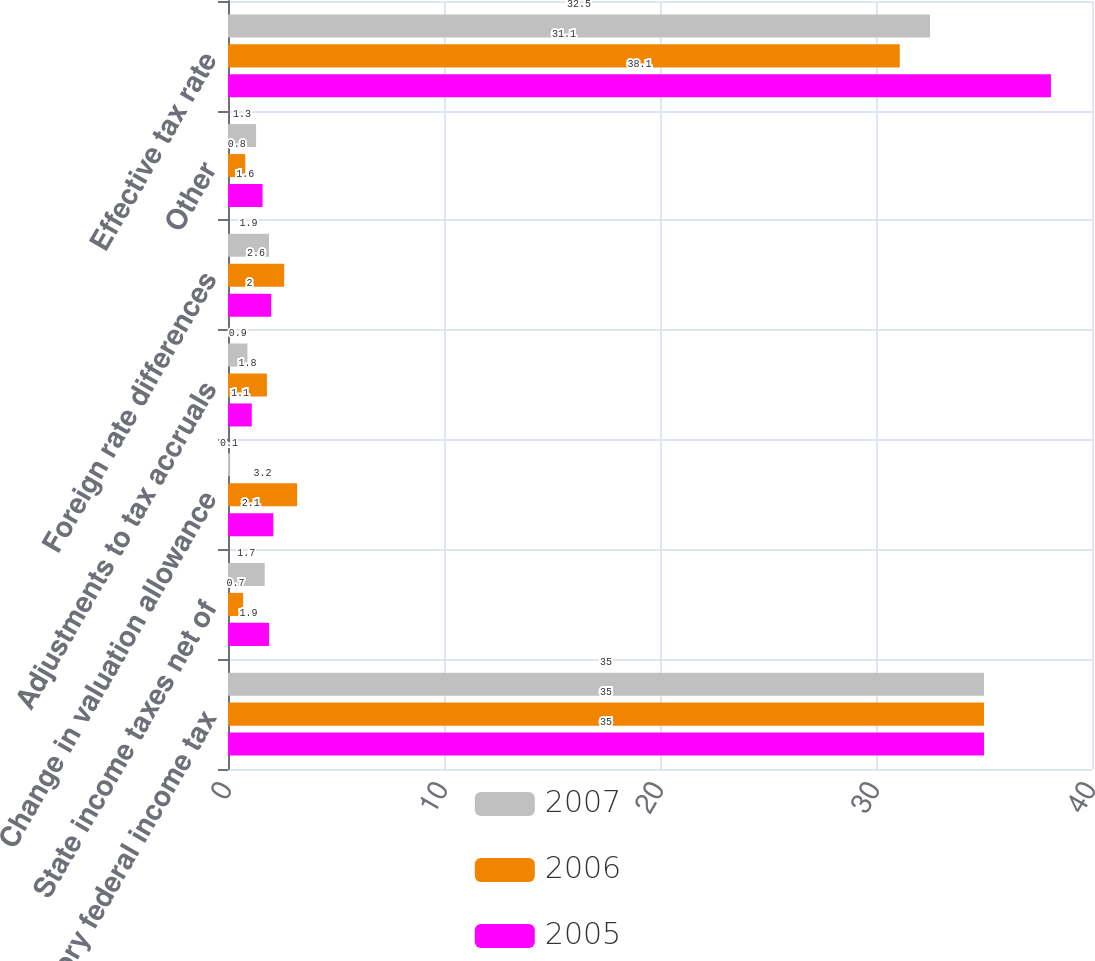Convert chart. <chart><loc_0><loc_0><loc_500><loc_500><stacked_bar_chart><ecel><fcel>Statutory federal income tax<fcel>State income taxes net of<fcel>Change in valuation allowance<fcel>Adjustments to tax accruals<fcel>Foreign rate differences<fcel>Other<fcel>Effective tax rate<nl><fcel>2007<fcel>35<fcel>1.7<fcel>0.1<fcel>0.9<fcel>1.9<fcel>1.3<fcel>32.5<nl><fcel>2006<fcel>35<fcel>0.7<fcel>3.2<fcel>1.8<fcel>2.6<fcel>0.8<fcel>31.1<nl><fcel>2005<fcel>35<fcel>1.9<fcel>2.1<fcel>1.1<fcel>2<fcel>1.6<fcel>38.1<nl></chart> 